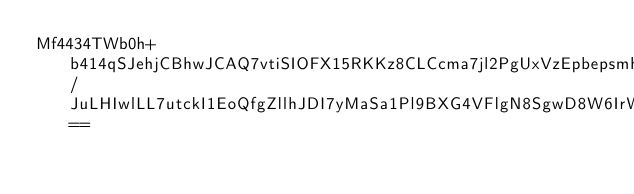Convert code to text. <code><loc_0><loc_0><loc_500><loc_500><_SML_>Mf4434TWb0h+b414qSJehjCBhwJCAQ7vtiSIOFX15RKKz8CLCcma7jl2PgUxVzEpbepsmh8ZRhMILrNabSakK2vsPGfZCyBSXfKvboDITz7Jytl55zuWAkFdycmAek9MUmDn/JuLHIwlLL7utckI1EoQfgZllhJDI7yMaSa1Pl9BXG4VFlgN8SgwD8W6IrWXqnVnpi3oKEqCpg==</code> 